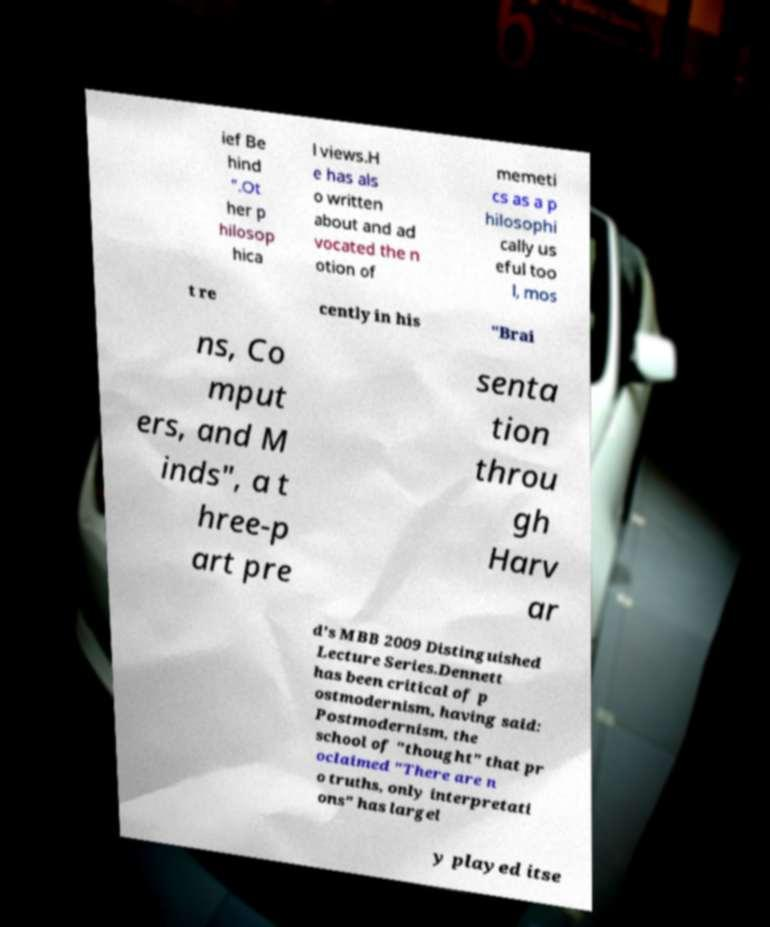Could you extract and type out the text from this image? ief Be hind ".Ot her p hilosop hica l views.H e has als o written about and ad vocated the n otion of memeti cs as a p hilosophi cally us eful too l, mos t re cently in his "Brai ns, Co mput ers, and M inds", a t hree-p art pre senta tion throu gh Harv ar d's MBB 2009 Distinguished Lecture Series.Dennett has been critical of p ostmodernism, having said: Postmodernism, the school of "thought" that pr oclaimed "There are n o truths, only interpretati ons" has largel y played itse 